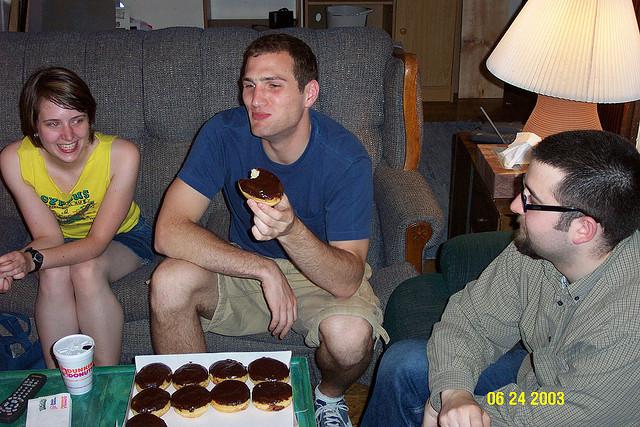How many women are eating pizza?
Write a very short answer. 0. What is for dessert?
Keep it brief. Donuts. Are the boys brothers?
Be succinct. No. Are the donuts filled?
Be succinct. Yes. Where were the donuts purchased from?
Write a very short answer. Dunkin donuts. What are these people eating?
Keep it brief. Donuts. What is the date of the picture?
Answer briefly. 06 24 2003. What are they eating?
Be succinct. Donuts. What is the guy holding?
Quick response, please. Donut. 